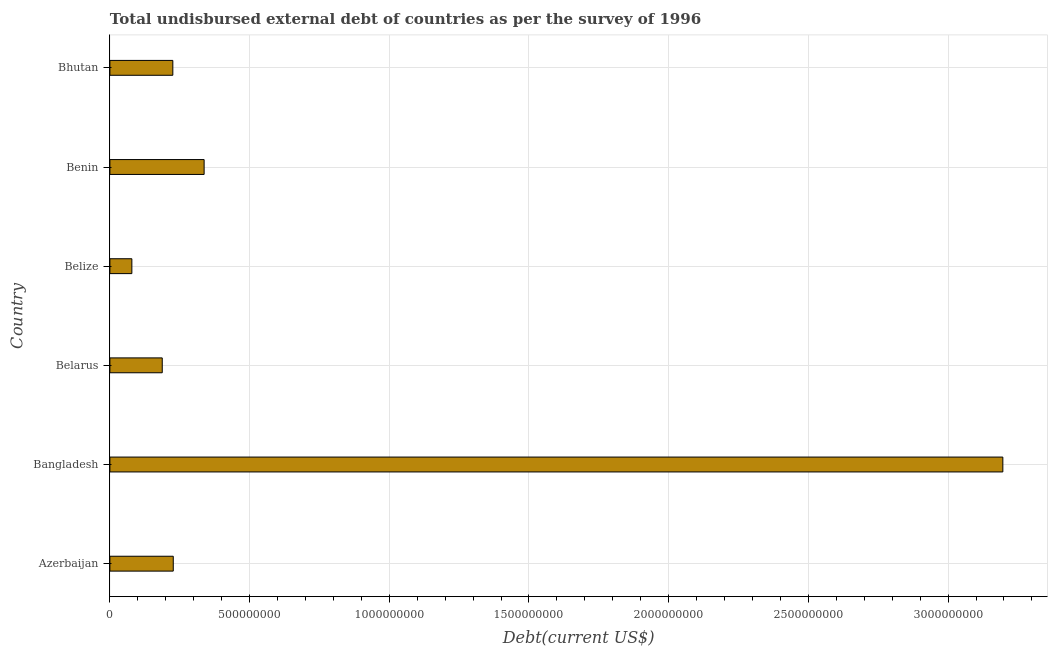Does the graph contain any zero values?
Provide a succinct answer. No. What is the title of the graph?
Offer a terse response. Total undisbursed external debt of countries as per the survey of 1996. What is the label or title of the X-axis?
Offer a very short reply. Debt(current US$). What is the total debt in Bangladesh?
Ensure brevity in your answer.  3.20e+09. Across all countries, what is the maximum total debt?
Ensure brevity in your answer.  3.20e+09. Across all countries, what is the minimum total debt?
Offer a very short reply. 7.87e+07. In which country was the total debt maximum?
Ensure brevity in your answer.  Bangladesh. In which country was the total debt minimum?
Provide a short and direct response. Belize. What is the sum of the total debt?
Provide a short and direct response. 4.25e+09. What is the difference between the total debt in Belarus and Belize?
Offer a very short reply. 1.09e+08. What is the average total debt per country?
Keep it short and to the point. 7.09e+08. What is the median total debt?
Make the answer very short. 2.26e+08. In how many countries, is the total debt greater than 400000000 US$?
Provide a succinct answer. 1. What is the ratio of the total debt in Azerbaijan to that in Belize?
Provide a short and direct response. 2.88. What is the difference between the highest and the second highest total debt?
Your answer should be very brief. 2.86e+09. Is the sum of the total debt in Azerbaijan and Belize greater than the maximum total debt across all countries?
Your answer should be very brief. No. What is the difference between the highest and the lowest total debt?
Make the answer very short. 3.12e+09. Are the values on the major ticks of X-axis written in scientific E-notation?
Provide a succinct answer. No. What is the Debt(current US$) of Azerbaijan?
Your answer should be very brief. 2.27e+08. What is the Debt(current US$) of Bangladesh?
Provide a short and direct response. 3.20e+09. What is the Debt(current US$) of Belarus?
Keep it short and to the point. 1.87e+08. What is the Debt(current US$) in Belize?
Provide a short and direct response. 7.87e+07. What is the Debt(current US$) of Benin?
Make the answer very short. 3.37e+08. What is the Debt(current US$) in Bhutan?
Offer a terse response. 2.25e+08. What is the difference between the Debt(current US$) in Azerbaijan and Bangladesh?
Offer a very short reply. -2.97e+09. What is the difference between the Debt(current US$) in Azerbaijan and Belarus?
Make the answer very short. 3.94e+07. What is the difference between the Debt(current US$) in Azerbaijan and Belize?
Your response must be concise. 1.48e+08. What is the difference between the Debt(current US$) in Azerbaijan and Benin?
Provide a succinct answer. -1.10e+08. What is the difference between the Debt(current US$) in Azerbaijan and Bhutan?
Make the answer very short. 1.54e+06. What is the difference between the Debt(current US$) in Bangladesh and Belarus?
Your answer should be compact. 3.01e+09. What is the difference between the Debt(current US$) in Bangladesh and Belize?
Offer a very short reply. 3.12e+09. What is the difference between the Debt(current US$) in Bangladesh and Benin?
Ensure brevity in your answer.  2.86e+09. What is the difference between the Debt(current US$) in Bangladesh and Bhutan?
Make the answer very short. 2.97e+09. What is the difference between the Debt(current US$) in Belarus and Belize?
Provide a short and direct response. 1.09e+08. What is the difference between the Debt(current US$) in Belarus and Benin?
Offer a very short reply. -1.50e+08. What is the difference between the Debt(current US$) in Belarus and Bhutan?
Provide a short and direct response. -3.79e+07. What is the difference between the Debt(current US$) in Belize and Benin?
Ensure brevity in your answer.  -2.59e+08. What is the difference between the Debt(current US$) in Belize and Bhutan?
Ensure brevity in your answer.  -1.47e+08. What is the difference between the Debt(current US$) in Benin and Bhutan?
Offer a very short reply. 1.12e+08. What is the ratio of the Debt(current US$) in Azerbaijan to that in Bangladesh?
Your response must be concise. 0.07. What is the ratio of the Debt(current US$) in Azerbaijan to that in Belarus?
Make the answer very short. 1.21. What is the ratio of the Debt(current US$) in Azerbaijan to that in Belize?
Provide a succinct answer. 2.88. What is the ratio of the Debt(current US$) in Azerbaijan to that in Benin?
Make the answer very short. 0.67. What is the ratio of the Debt(current US$) in Azerbaijan to that in Bhutan?
Ensure brevity in your answer.  1.01. What is the ratio of the Debt(current US$) in Bangladesh to that in Belarus?
Provide a succinct answer. 17.06. What is the ratio of the Debt(current US$) in Bangladesh to that in Belize?
Your answer should be compact. 40.63. What is the ratio of the Debt(current US$) in Bangladesh to that in Benin?
Offer a terse response. 9.48. What is the ratio of the Debt(current US$) in Bangladesh to that in Bhutan?
Your answer should be compact. 14.19. What is the ratio of the Debt(current US$) in Belarus to that in Belize?
Your answer should be very brief. 2.38. What is the ratio of the Debt(current US$) in Belarus to that in Benin?
Your answer should be compact. 0.56. What is the ratio of the Debt(current US$) in Belarus to that in Bhutan?
Keep it short and to the point. 0.83. What is the ratio of the Debt(current US$) in Belize to that in Benin?
Your answer should be very brief. 0.23. What is the ratio of the Debt(current US$) in Belize to that in Bhutan?
Your answer should be compact. 0.35. What is the ratio of the Debt(current US$) in Benin to that in Bhutan?
Provide a succinct answer. 1.5. 